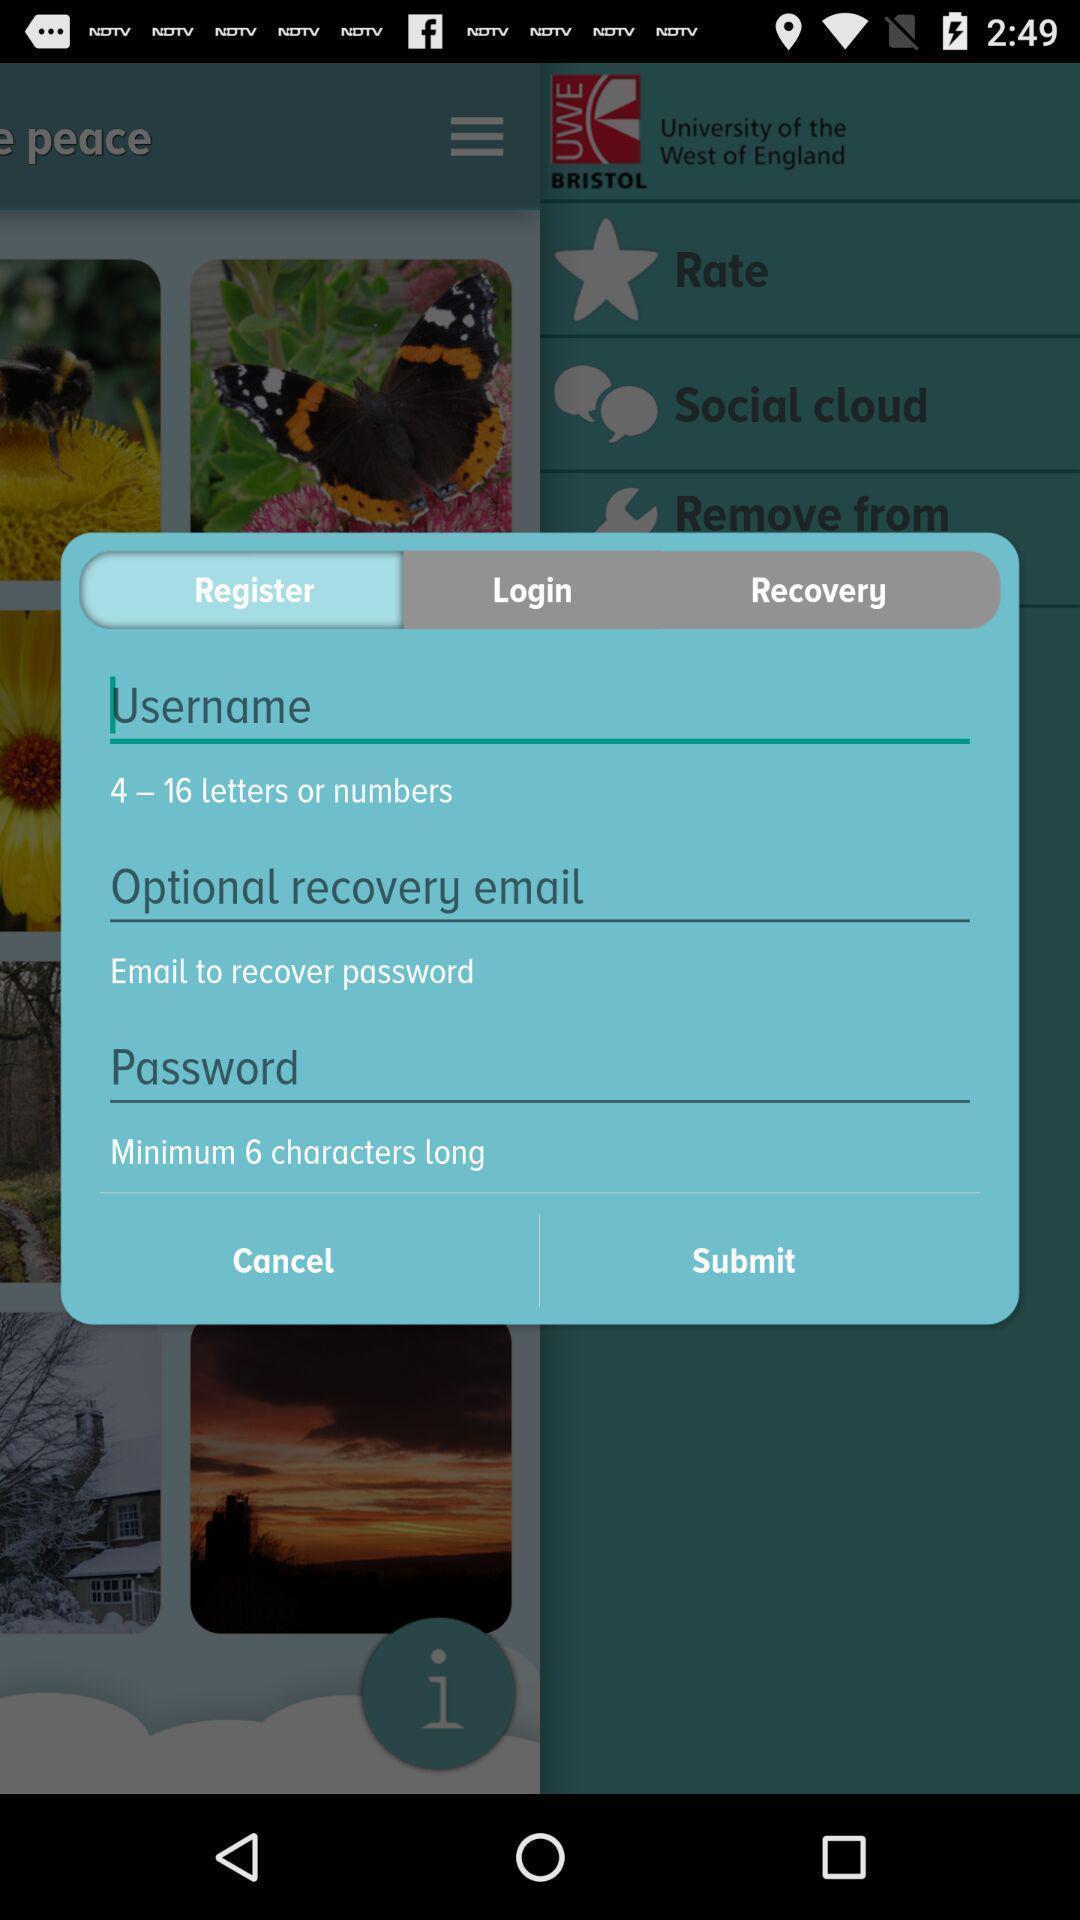Tell me about the visual elements in this screen capture. Popup to sign up. 